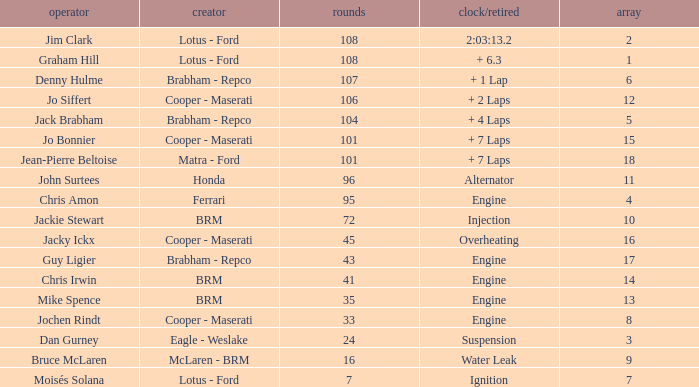What was the grid for suspension time/retired? 3.0. 